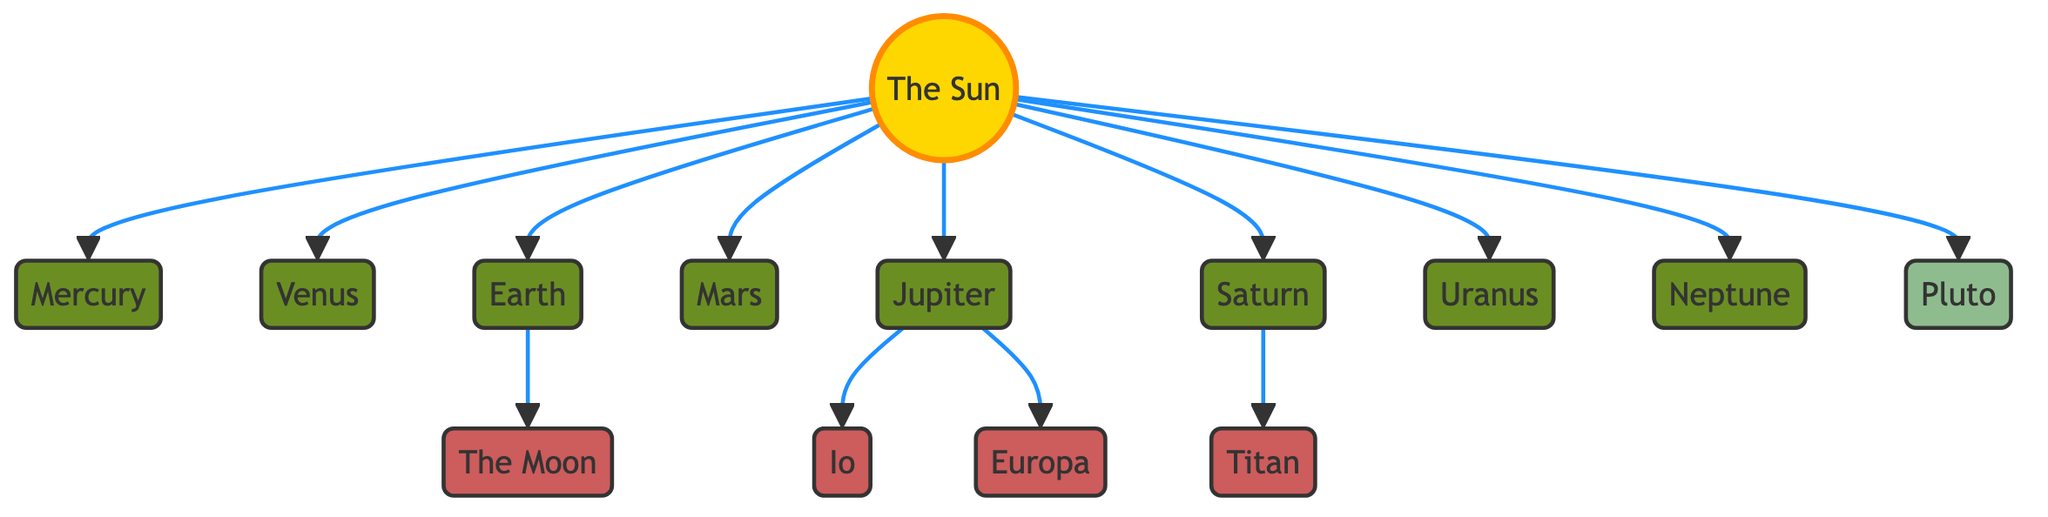What is the largest planet depicted in the diagram? The largest planet in the diagram is identified as Jupiter. In the flowchart, Jupiter is placed further from the sun compared to the inner planets and is distinctly labeled among the planets.
Answer: Jupiter How many moons are associated with Jupiter in the diagram? In the diagram, Jupiter is linked to two moons, Io and Europa. By counting the connected nodes specifically labeled as moons, we identify the total.
Answer: 2 Which planet has a direct relationship with Earth according to the diagram? The moon, The Moon, is directly connected to Earth as a satellite. In the flowchart, The Moon is shown as a connected node under Earth.
Answer: The Moon What color represents the planets in the diagram? The planets in the diagram are represented in a dark green color (hex code: #6b8e23) according to the defined class styles. This is evident by the visual coloration of all planets in the diagram.
Answer: Dark Green Which celestial body is marked as a dwarf planet? The diagram specifically labels Pluto as the dwarf planet. By observing the classification and connection structure in the flowchart, Pluto stands out among the other categories of celestial bodies.
Answer: Pluto Which planet has Titan as a moon? Titan is the moon associated with Saturn. In the diagram, Titan is shown as a connected node branching from Saturn, indicating its relationship.
Answer: Saturn How many planets are depicted in the diagram? The total number of planets in the diagram includes Mercury, Venus, Earth, Mars, Jupiter, Saturn, Uranus, and Neptune, totaling eight planets altogether. The counting is straightforward by identifying all the labeled planet nodes.
Answer: 8 What distinguishes the Sun from other celestial bodies in the diagram? The Sun is classified as a star and has a different visual style indicated by a gold color (hex code: #ffd700) and a larger font size compared to the planets and moons. Thus, its classification stands out clearly.
Answer: Star Which planet is closest to the Sun according to the diagram? Mercury is the planet closest to the Sun, as shown in the flowchart with a direct edge from the Sun to Mercury, indicating its position within the solar system.
Answer: Mercury 